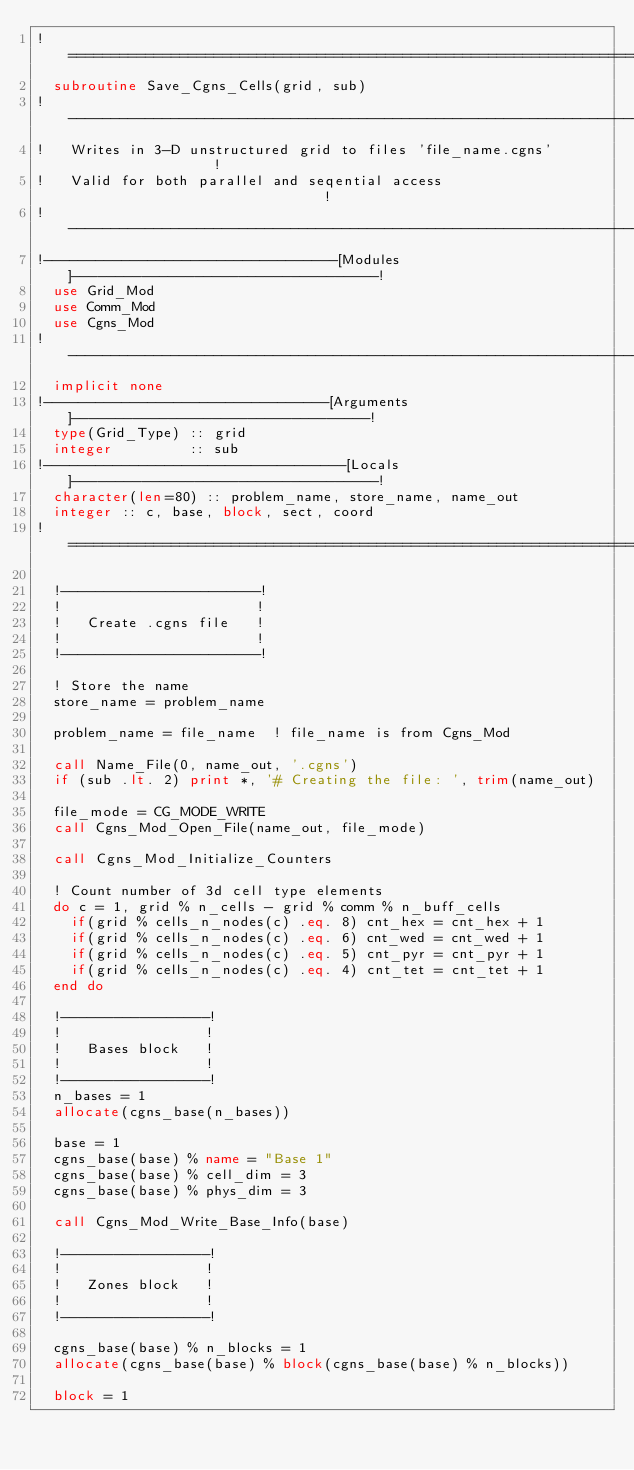Convert code to text. <code><loc_0><loc_0><loc_500><loc_500><_FORTRAN_>!==============================================================================!
  subroutine Save_Cgns_Cells(grid, sub)
!------------------------------------------------------------------------------!
!   Writes in 3-D unstructured grid to files 'file_name.cgns'                  !
!   Valid for both parallel and seqential access                               !
!------------------------------------------------------------------------------!
!----------------------------------[Modules]-----------------------------------!
  use Grid_Mod
  use Comm_Mod
  use Cgns_Mod
!------------------------------------------------------------------------------!
  implicit none
!---------------------------------[Arguments]----------------------------------!
  type(Grid_Type) :: grid
  integer         :: sub
!-----------------------------------[Locals]-----------------------------------!
  character(len=80) :: problem_name, store_name, name_out
  integer :: c, base, block, sect, coord
!==============================================================================!

  !-----------------------!
  !                       !
  !   Create .cgns file   !
  !                       !
  !-----------------------!

  ! Store the name
  store_name = problem_name

  problem_name = file_name  ! file_name is from Cgns_Mod

  call Name_File(0, name_out, '.cgns')
  if (sub .lt. 2) print *, '# Creating the file: ', trim(name_out)

  file_mode = CG_MODE_WRITE
  call Cgns_Mod_Open_File(name_out, file_mode)

  call Cgns_Mod_Initialize_Counters

  ! Count number of 3d cell type elements
  do c = 1, grid % n_cells - grid % comm % n_buff_cells
    if(grid % cells_n_nodes(c) .eq. 8) cnt_hex = cnt_hex + 1
    if(grid % cells_n_nodes(c) .eq. 6) cnt_wed = cnt_wed + 1
    if(grid % cells_n_nodes(c) .eq. 5) cnt_pyr = cnt_pyr + 1
    if(grid % cells_n_nodes(c) .eq. 4) cnt_tet = cnt_tet + 1
  end do

  !-----------------!
  !                 !
  !   Bases block   !
  !                 !
  !-----------------!
  n_bases = 1
  allocate(cgns_base(n_bases))

  base = 1
  cgns_base(base) % name = "Base 1"
  cgns_base(base) % cell_dim = 3
  cgns_base(base) % phys_dim = 3

  call Cgns_Mod_Write_Base_Info(base)

  !-----------------!
  !                 !
  !   Zones block   !
  !                 !
  !-----------------!

  cgns_base(base) % n_blocks = 1
  allocate(cgns_base(base) % block(cgns_base(base) % n_blocks))

  block = 1</code> 